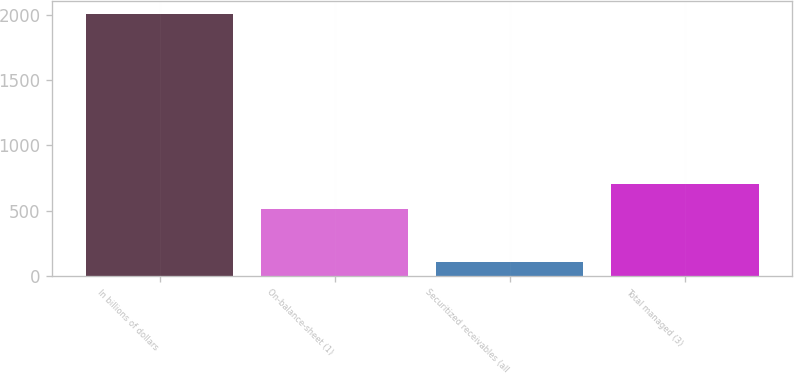Convert chart. <chart><loc_0><loc_0><loc_500><loc_500><bar_chart><fcel>In billions of dollars<fcel>On-balance-sheet (1)<fcel>Securitized receivables (all<fcel>Total managed (3)<nl><fcel>2008<fcel>515.7<fcel>105.9<fcel>705.91<nl></chart> 